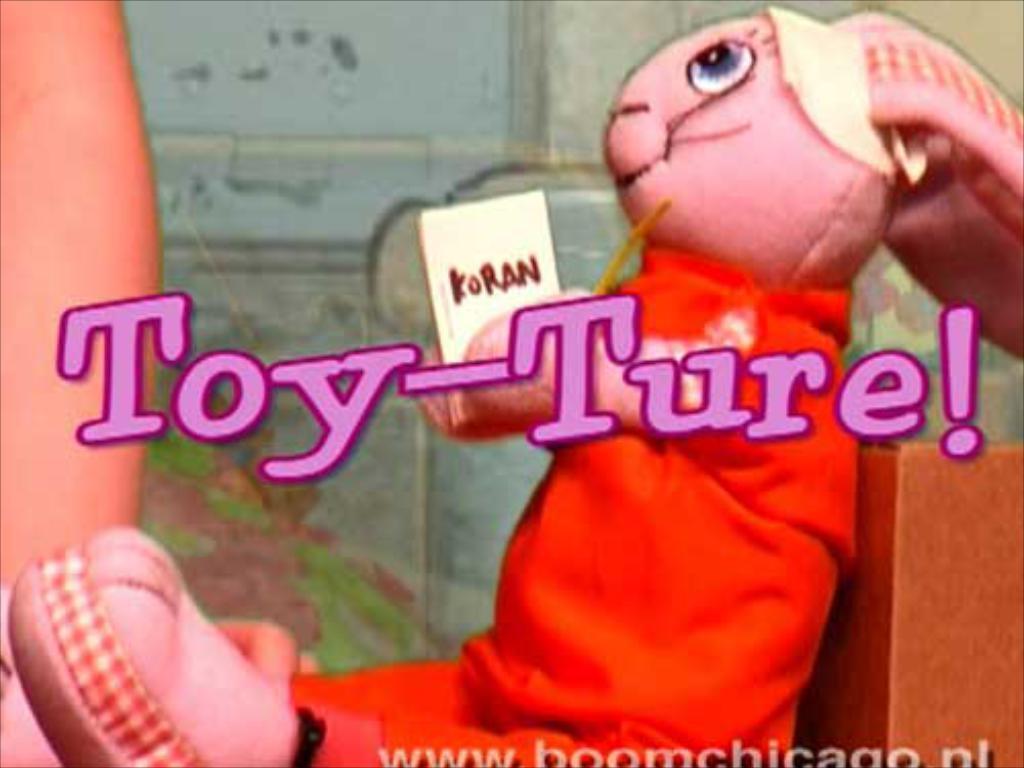Please provide a concise description of this image. This image consists of a toy. It is having a red dress. In the background, we can see a wall. In the middle, there is a text. 